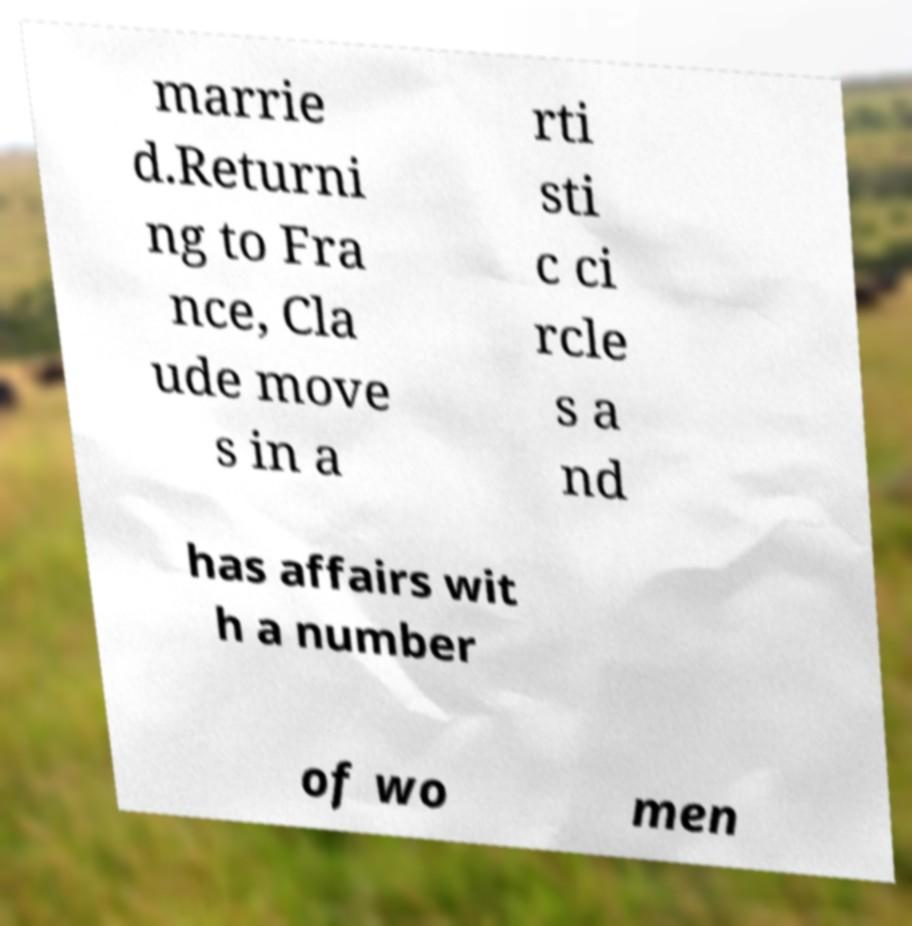What messages or text are displayed in this image? I need them in a readable, typed format. marrie d.Returni ng to Fra nce, Cla ude move s in a rti sti c ci rcle s a nd has affairs wit h a number of wo men 